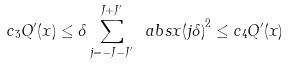Convert formula to latex. <formula><loc_0><loc_0><loc_500><loc_500>c _ { 3 } Q ^ { \prime } ( x ) \leq \delta \sum _ { j = - J - J ^ { \prime } } ^ { J + J ^ { \prime } } \ a b s { x ( j \delta ) } ^ { 2 } \leq c _ { 4 } Q ^ { \prime } ( x )</formula> 